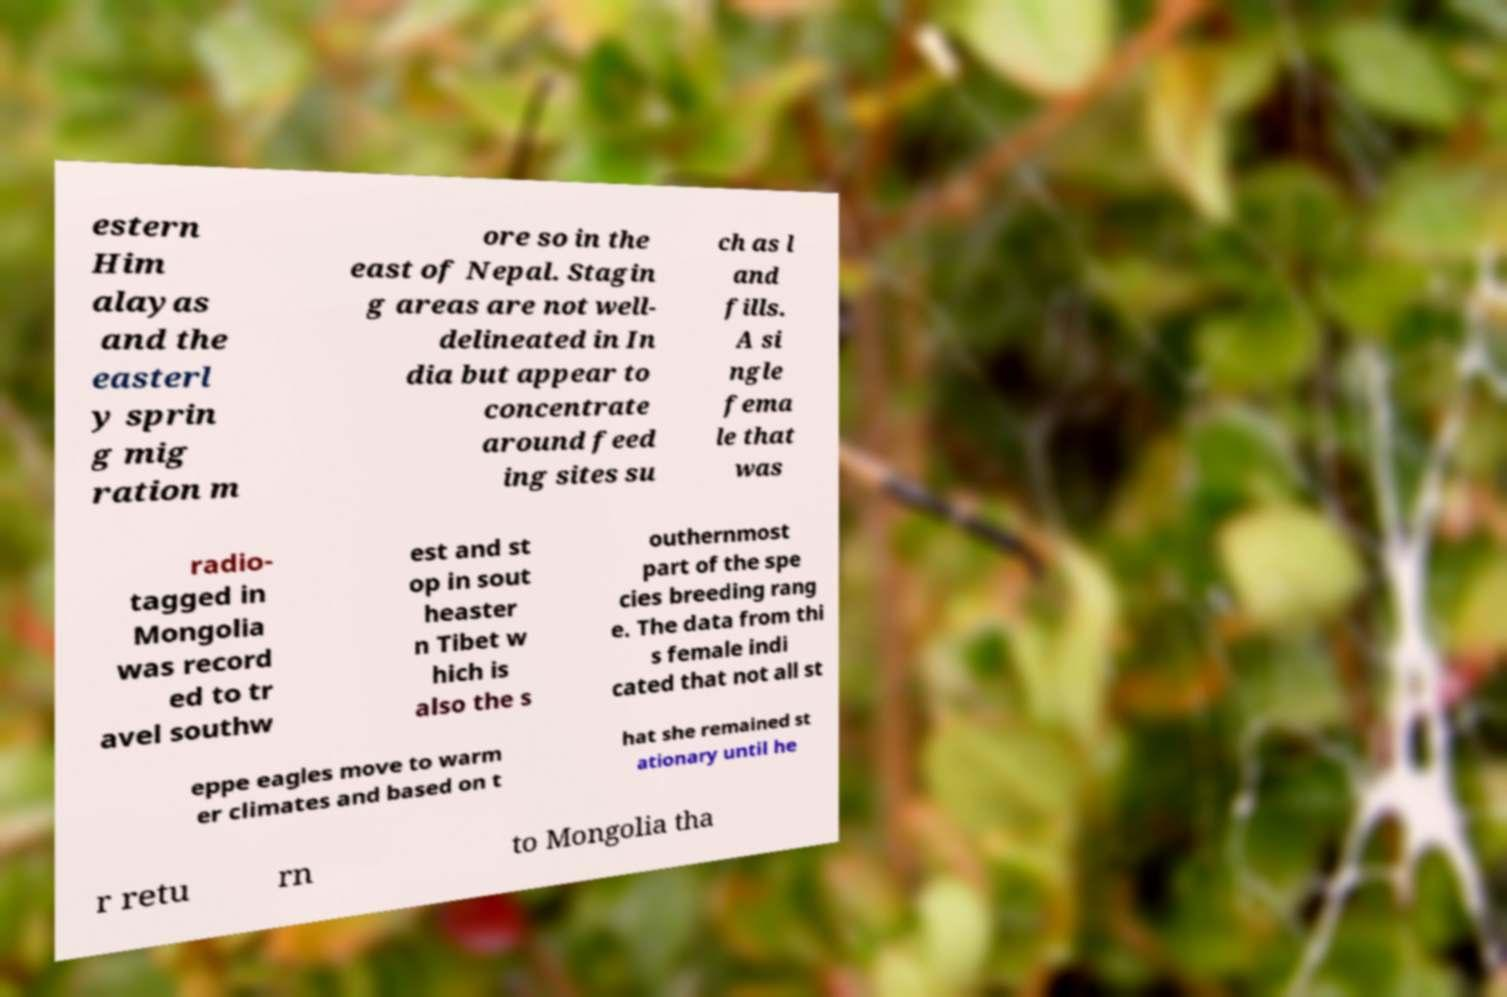For documentation purposes, I need the text within this image transcribed. Could you provide that? estern Him alayas and the easterl y sprin g mig ration m ore so in the east of Nepal. Stagin g areas are not well- delineated in In dia but appear to concentrate around feed ing sites su ch as l and fills. A si ngle fema le that was radio- tagged in Mongolia was record ed to tr avel southw est and st op in sout heaster n Tibet w hich is also the s outhernmost part of the spe cies breeding rang e. The data from thi s female indi cated that not all st eppe eagles move to warm er climates and based on t hat she remained st ationary until he r retu rn to Mongolia tha 